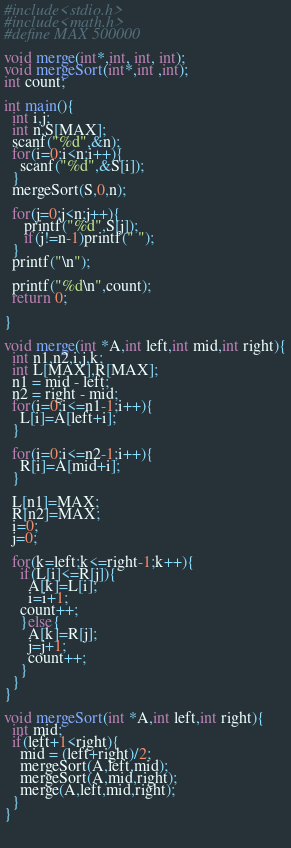Convert code to text. <code><loc_0><loc_0><loc_500><loc_500><_C_>#include<stdio.h>
#include<math.h>
#define MAX 500000

void merge(int*,int, int, int);
void mergeSort(int*,int ,int); 
int count;

int main(){
  int i,j;
  int n,S[MAX];
  scanf("%d",&n);
  for(i=0;i<n;i++){
    scanf("%d",&S[i]);
  }
  mergeSort(S,0,n);

  for(j=0;j<n;j++){
     printf("%d",S[j]);
     if(j!=n-1)printf(" ");
  }
  printf("\n");
   
  printf("%d\n",count);
  return 0;
  
}  

void merge(int *A,int left,int mid,int right){
  int n1,n2,i,j,k;
  int L[MAX],R[MAX];
  n1 = mid - left;
  n2 = right - mid;
  for(i=0;i<=n1-1;i++){
    L[i]=A[left+i];
  }

  for(i=0;i<=n2-1;i++){
    R[i]=A[mid+i];
  }
  
  L[n1]=MAX;
  R[n2]=MAX;
  i=0;
  j=0;

  for(k=left;k<=right-1;k++){
    if(L[i]<=R[j]){
      A[k]=L[i];
      i=i+1;
    count++;  
    }else{
      A[k]=R[j];
      j=j+1;
      count++;
    }
  }
}

void mergeSort(int *A,int left,int right){
  int mid;  
  if(left+1<right){
    mid = (left+right)/2;
    mergeSort(A,left,mid);
    mergeSort(A,mid,right);
    merge(A,left,mid,right);
  }
}

  

</code> 